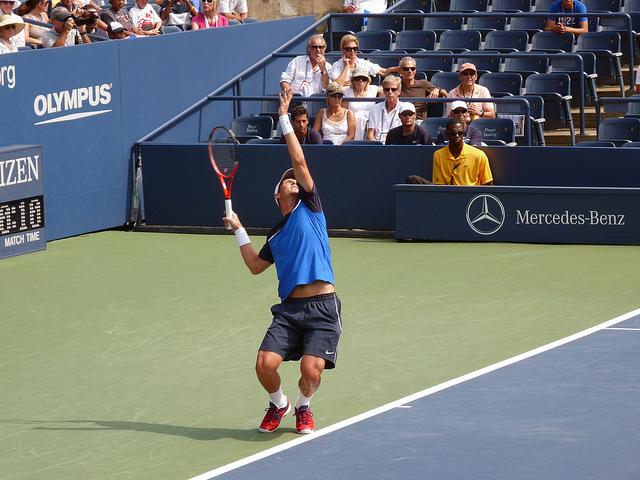Is this man playing professional tennis?
Answer briefly. Yes. What car brand is advertising?
Give a very brief answer. Mercedes-benz. What car is being advertised?
Be succinct. Mercedes-benz. Who is playing?
Concise answer only. Man. At what time was this picture taken?
Give a very brief answer. Day. Is the player catching the ball?
Give a very brief answer. No. Is this a backhand tennis stance or a serve stance?
Be succinct. Serve. 